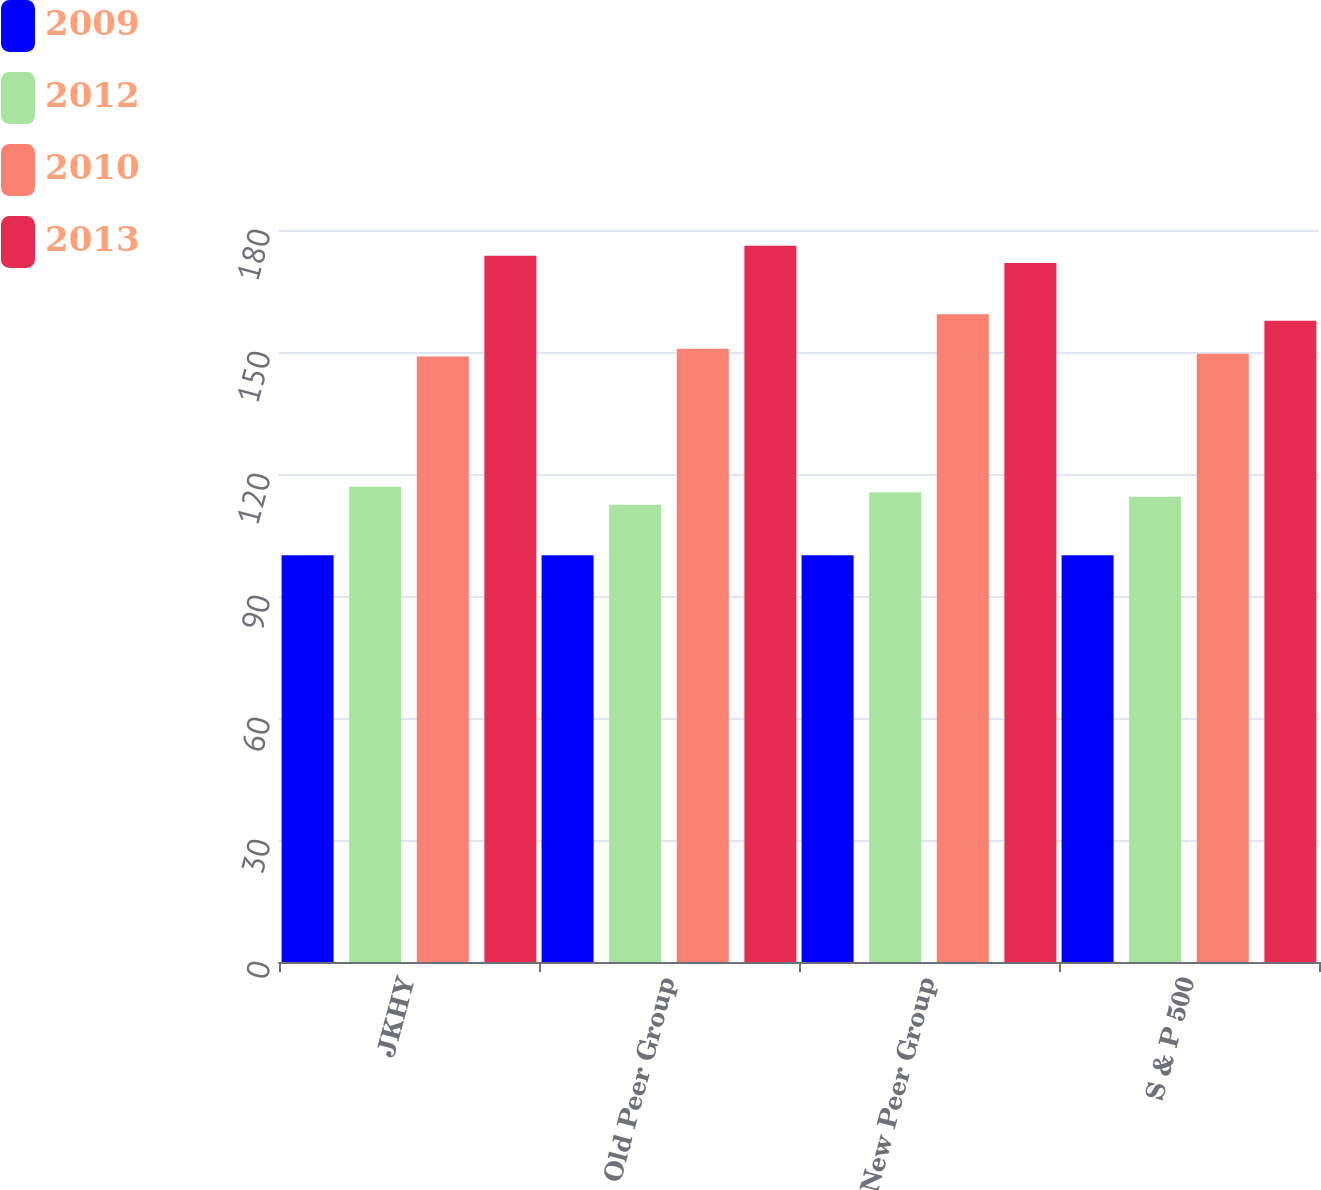<chart> <loc_0><loc_0><loc_500><loc_500><stacked_bar_chart><ecel><fcel>JKHY<fcel>Old Peer Group<fcel>New Peer Group<fcel>S & P 500<nl><fcel>2009<fcel>100<fcel>100<fcel>100<fcel>100<nl><fcel>2012<fcel>116.85<fcel>112.45<fcel>115.5<fcel>114.43<nl><fcel>2010<fcel>148.92<fcel>150.77<fcel>159.31<fcel>149.55<nl><fcel>2013<fcel>173.67<fcel>176.12<fcel>171.86<fcel>157.7<nl></chart> 